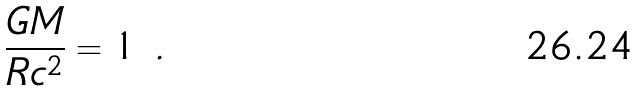<formula> <loc_0><loc_0><loc_500><loc_500>\frac { G M } { R c ^ { 2 } } = 1 \ .</formula> 